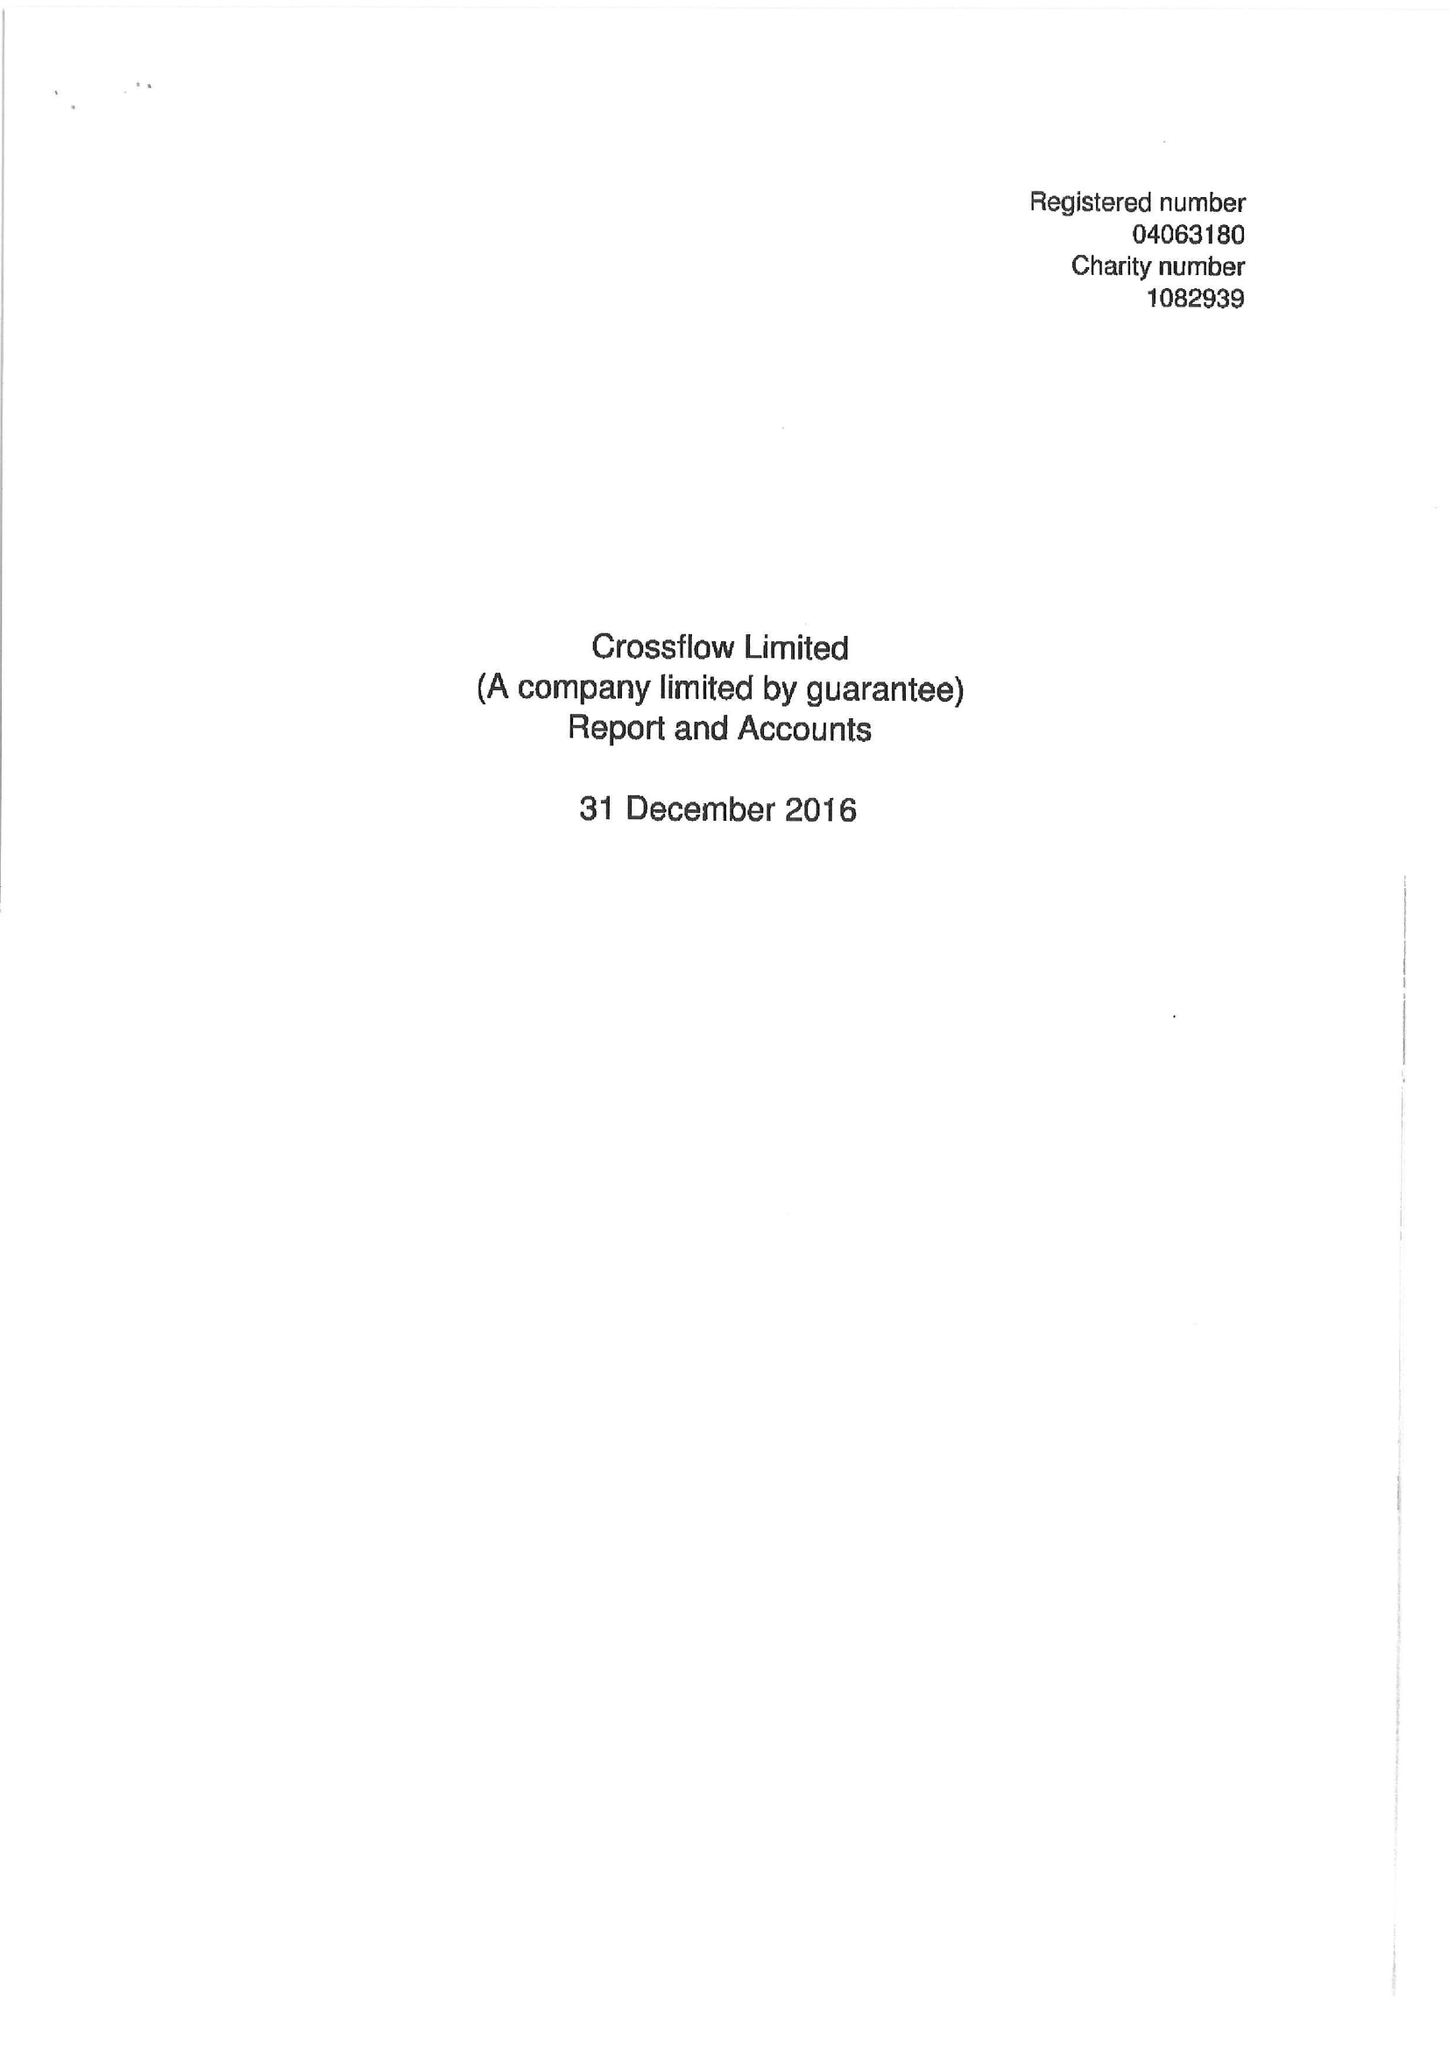What is the value for the address__street_line?
Answer the question using a single word or phrase. 83 VICTORIA STREET 